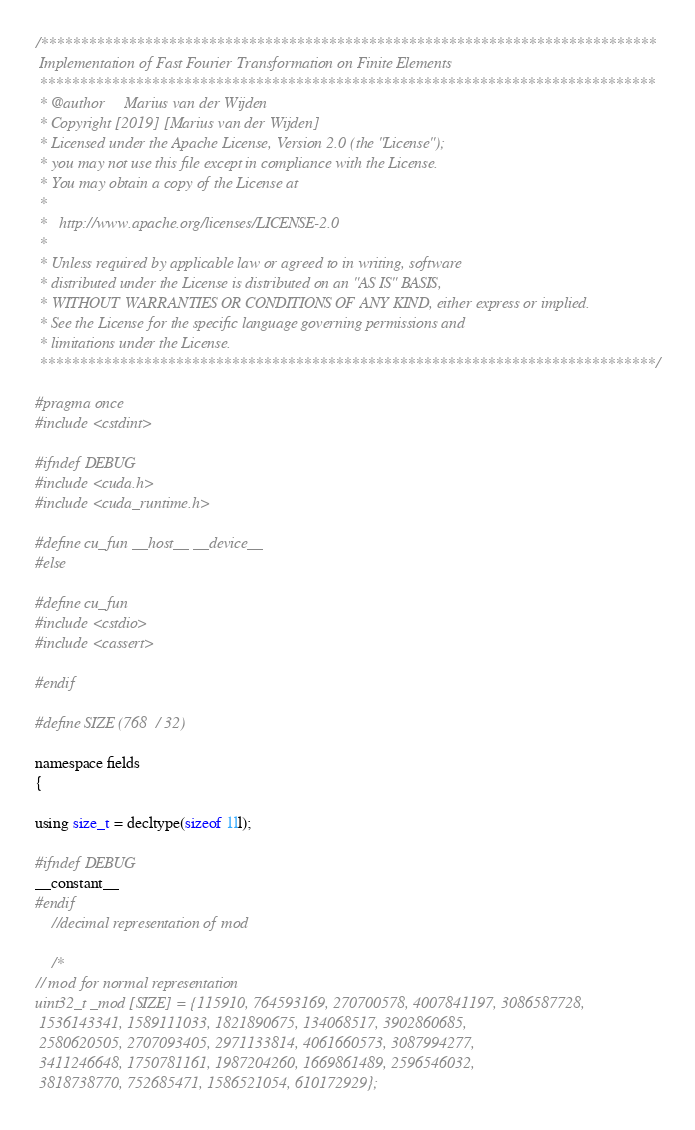Convert code to text. <code><loc_0><loc_0><loc_500><loc_500><_C_>/*****************************************************************************
 Implementation of Fast Fourier Transformation on Finite Elements
 *****************************************************************************
 * @author     Marius van der Wijden
 * Copyright [2019] [Marius van der Wijden]
 * Licensed under the Apache License, Version 2.0 (the "License");
 * you may not use this file except in compliance with the License.
 * You may obtain a copy of the License at
 *
 *   http://www.apache.org/licenses/LICENSE-2.0
 *
 * Unless required by applicable law or agreed to in writing, software
 * distributed under the License is distributed on an "AS IS" BASIS,
 * WITHOUT WARRANTIES OR CONDITIONS OF ANY KIND, either express or implied.
 * See the License for the specific language governing permissions and
 * limitations under the License.
 *****************************************************************************/

#pragma once
#include <cstdint>

#ifndef DEBUG
#include <cuda.h>
#include <cuda_runtime.h>

#define cu_fun __host__ __device__
#else

#define cu_fun
#include <cstdio>
#include <cassert>

#endif

#define SIZE (768 / 32)

namespace fields
{

using size_t = decltype(sizeof 1ll);

#ifndef DEBUG
__constant__
#endif
    //decimal representation of mod

    /*
// mod for normal representation
uint32_t _mod [SIZE] = {115910, 764593169, 270700578, 4007841197, 3086587728, 
 1536143341, 1589111033, 1821890675, 134068517, 3902860685, 
 2580620505, 2707093405, 2971133814, 4061660573, 3087994277, 
 3411246648, 1750781161, 1987204260, 1669861489, 2596546032, 
 3818738770, 752685471, 1586521054, 610172929};
</code> 